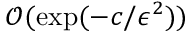<formula> <loc_0><loc_0><loc_500><loc_500>\mathcal { O } ( \exp ( - c / \epsilon ^ { 2 } ) )</formula> 